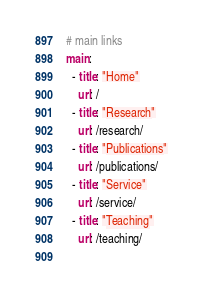Convert code to text. <code><loc_0><loc_0><loc_500><loc_500><_YAML_># main links
main:
  - title: "Home"
    url: /
  - title: "Research"
    url: /research/
  - title: "Publications"
    url: /publications/
  - title: "Service"
    url: /service/
  - title: "Teaching"
    url: /teaching/
  </code> 